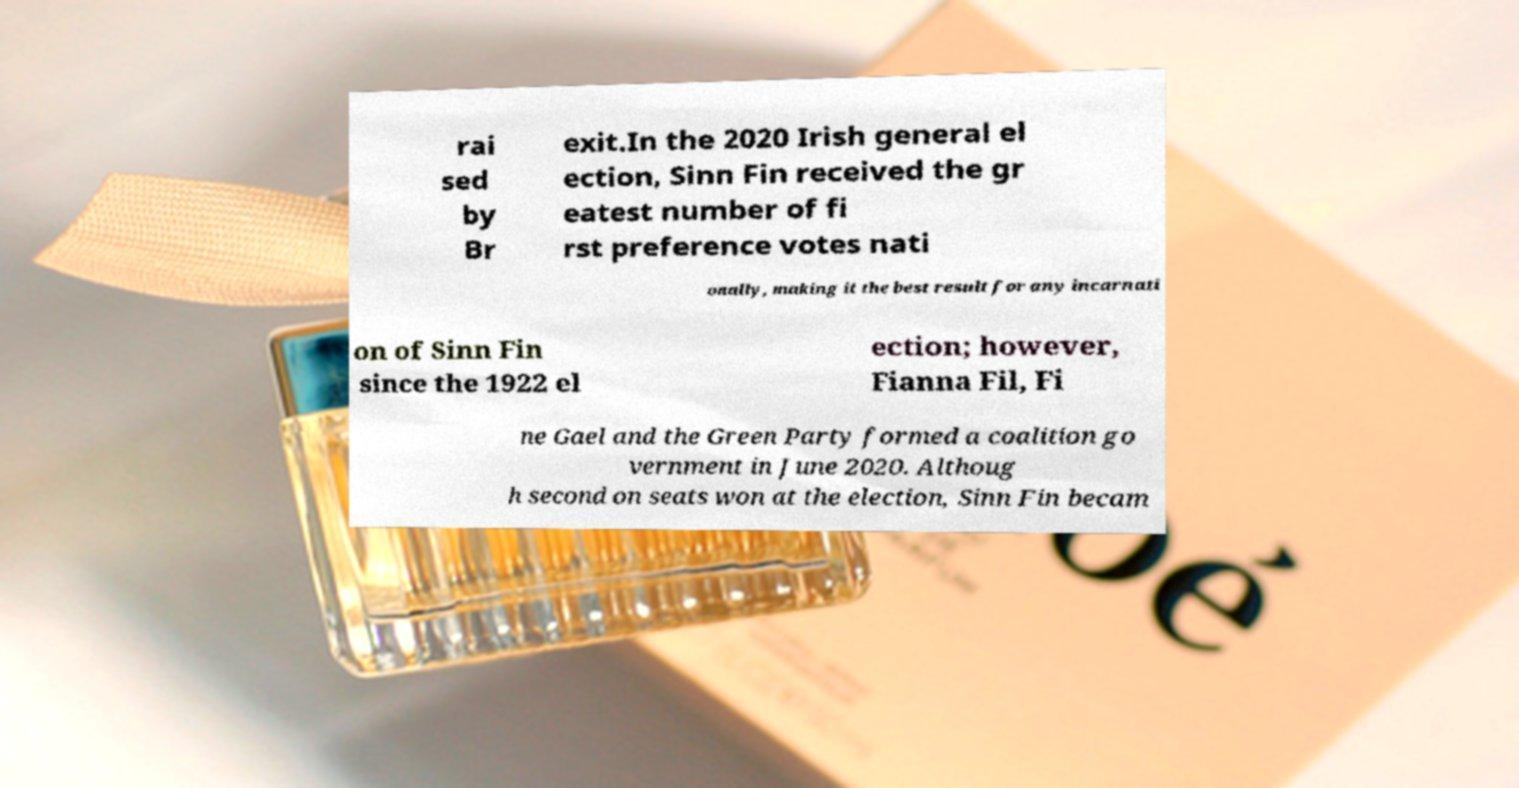What messages or text are displayed in this image? I need them in a readable, typed format. rai sed by Br exit.In the 2020 Irish general el ection, Sinn Fin received the gr eatest number of fi rst preference votes nati onally, making it the best result for any incarnati on of Sinn Fin since the 1922 el ection; however, Fianna Fil, Fi ne Gael and the Green Party formed a coalition go vernment in June 2020. Althoug h second on seats won at the election, Sinn Fin becam 